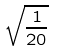Convert formula to latex. <formula><loc_0><loc_0><loc_500><loc_500>\sqrt { \frac { 1 } { 2 0 } }</formula> 